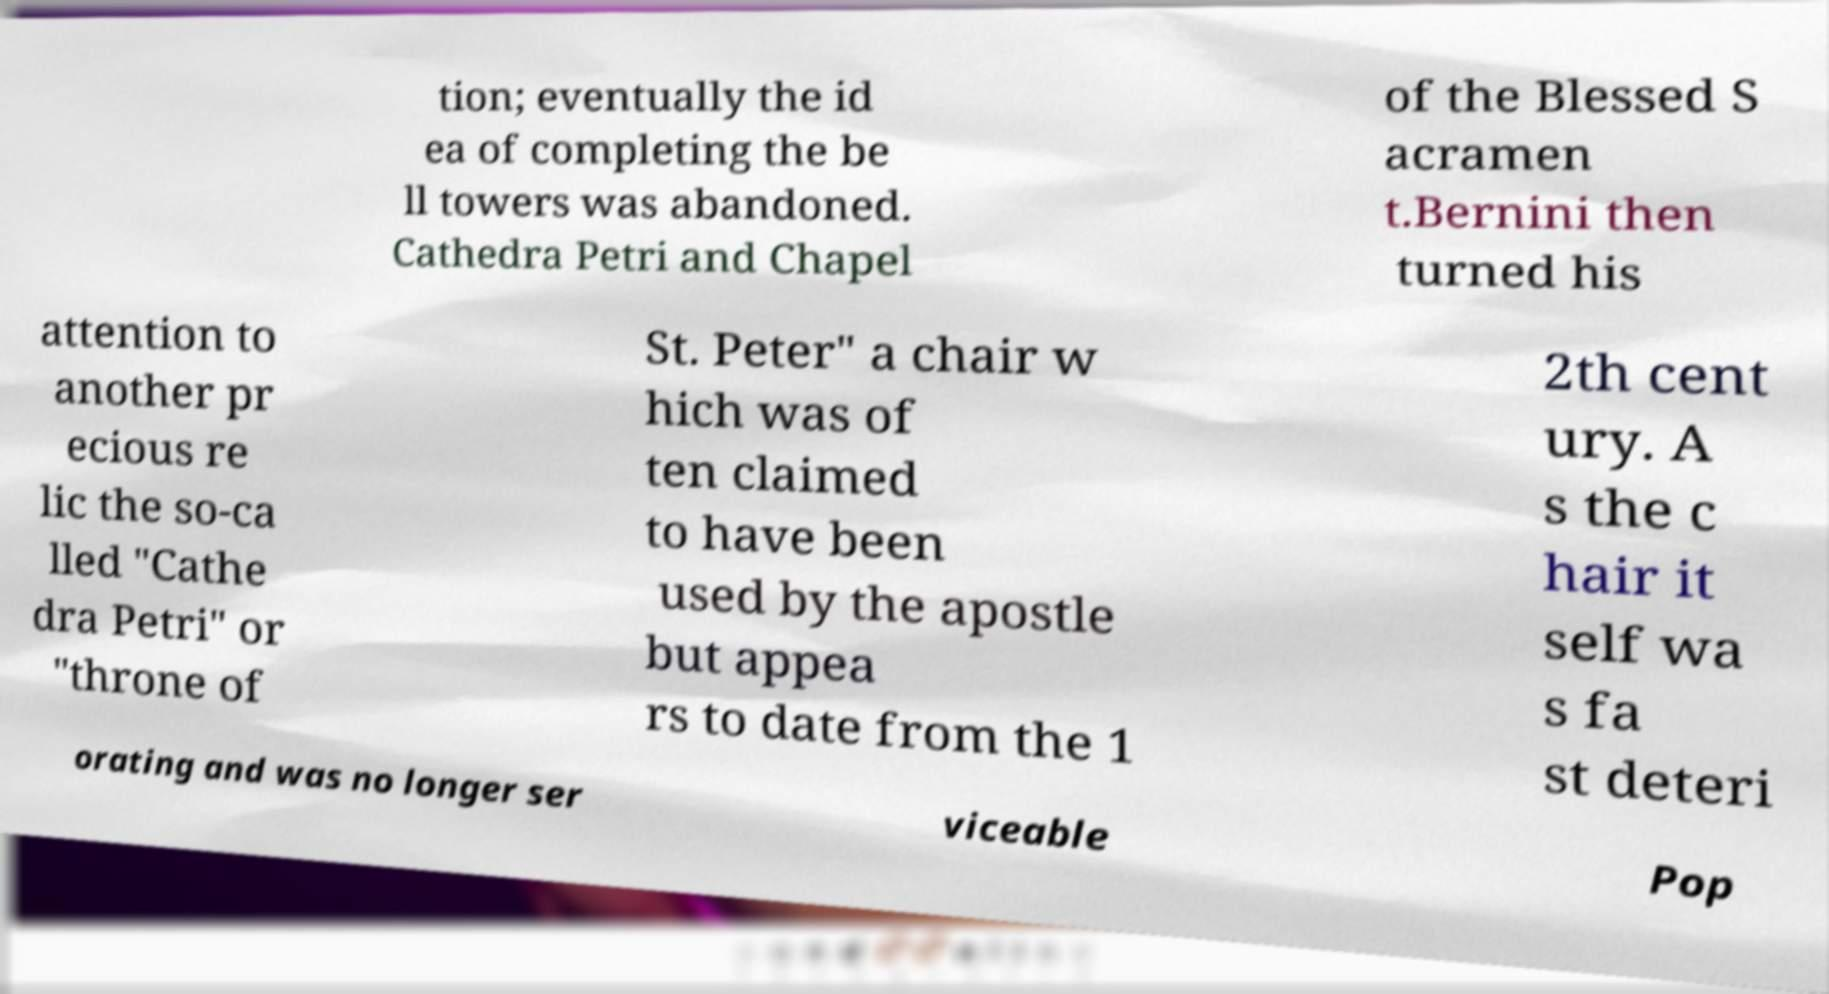I need the written content from this picture converted into text. Can you do that? tion; eventually the id ea of completing the be ll towers was abandoned. Cathedra Petri and Chapel of the Blessed S acramen t.Bernini then turned his attention to another pr ecious re lic the so-ca lled "Cathe dra Petri" or "throne of St. Peter" a chair w hich was of ten claimed to have been used by the apostle but appea rs to date from the 1 2th cent ury. A s the c hair it self wa s fa st deteri orating and was no longer ser viceable Pop 